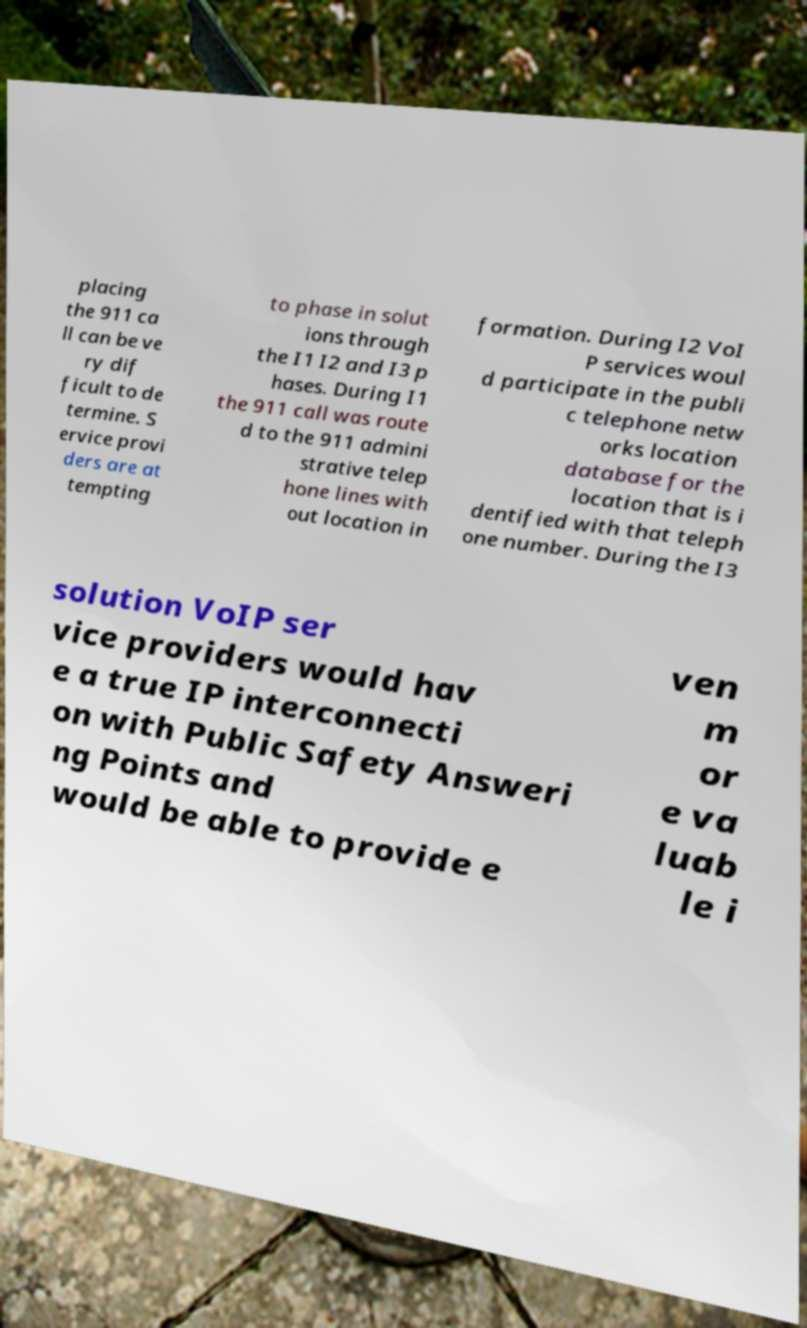I need the written content from this picture converted into text. Can you do that? placing the 911 ca ll can be ve ry dif ficult to de termine. S ervice provi ders are at tempting to phase in solut ions through the I1 I2 and I3 p hases. During I1 the 911 call was route d to the 911 admini strative telep hone lines with out location in formation. During I2 VoI P services woul d participate in the publi c telephone netw orks location database for the location that is i dentified with that teleph one number. During the I3 solution VoIP ser vice providers would hav e a true IP interconnecti on with Public Safety Answeri ng Points and would be able to provide e ven m or e va luab le i 